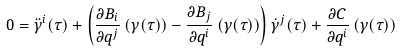Convert formula to latex. <formula><loc_0><loc_0><loc_500><loc_500>0 = \ddot { \gamma } ^ { i } ( \tau ) + \left ( \frac { \partial B _ { i } } { \partial q ^ { j } } \left ( \gamma ( \tau ) \right ) - \frac { \partial B _ { j } } { \partial q ^ { i } } \left ( \gamma ( \tau ) \right ) \right ) \dot { \gamma } ^ { j } ( \tau ) + \frac { \partial C } { \partial q ^ { i } } \left ( \gamma ( \tau ) \right )</formula> 